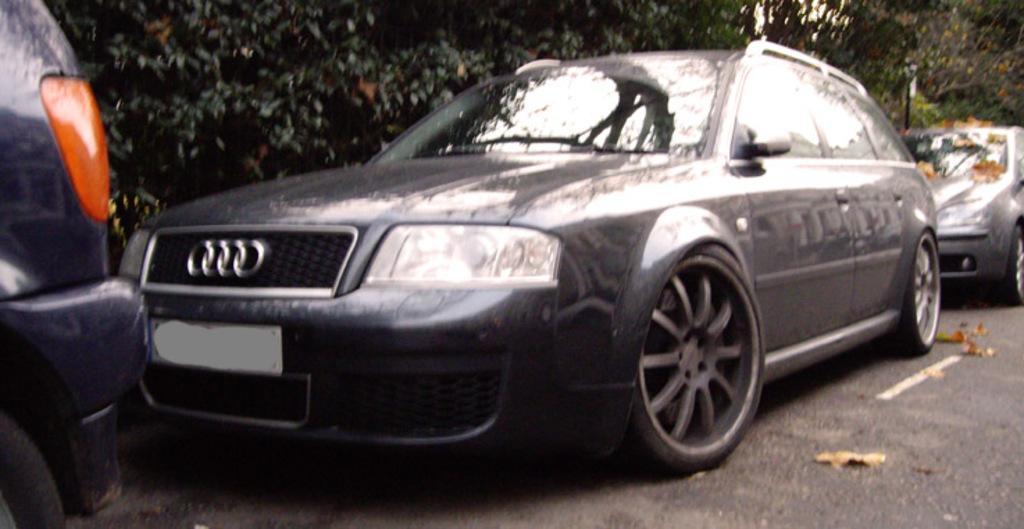Please provide a concise description of this image. In this picture I can see vehicles parked on the road, and in the background there are trees. 